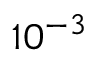<formula> <loc_0><loc_0><loc_500><loc_500>1 0 ^ { - 3 }</formula> 